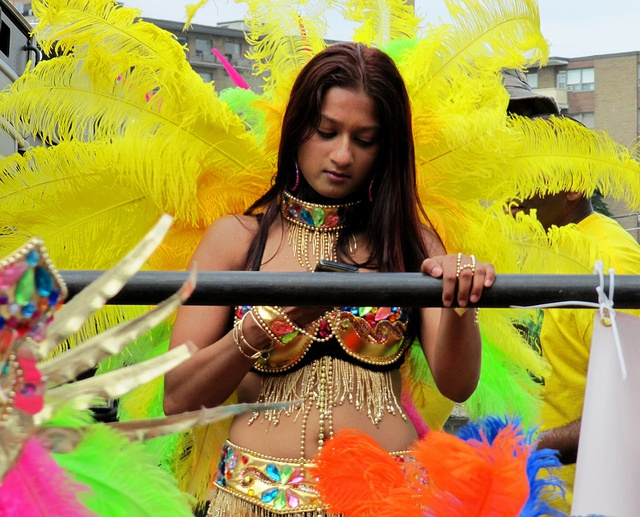Describe the objects in this image and their specific colors. I can see people in black, maroon, salmon, and tan tones and cell phone in black, gray, darkgreen, and blue tones in this image. 